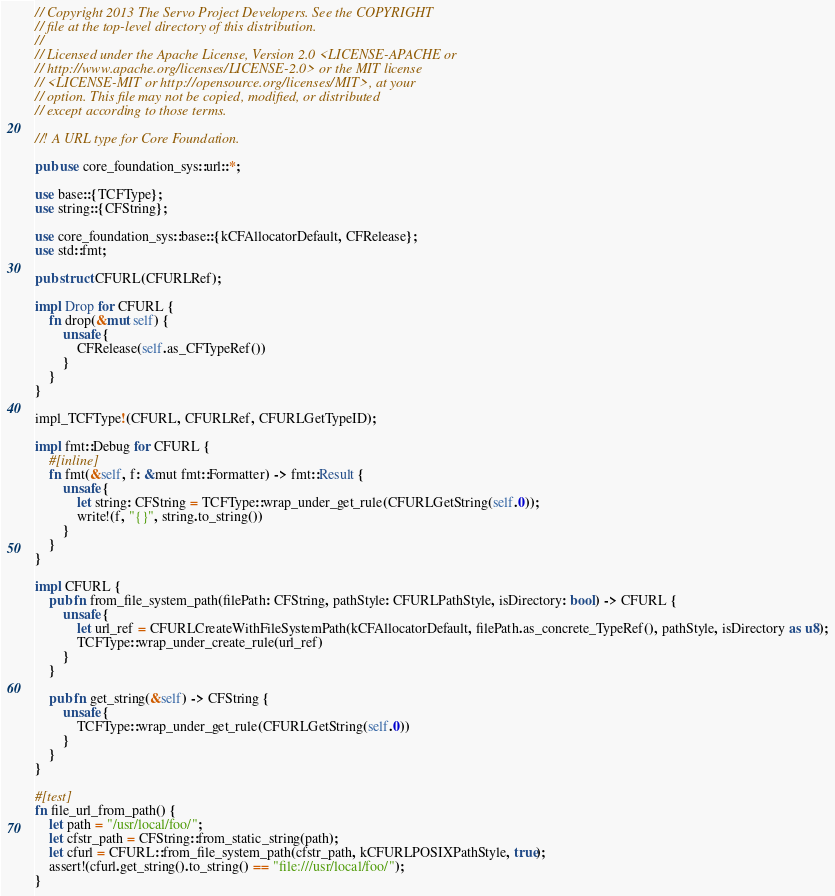<code> <loc_0><loc_0><loc_500><loc_500><_Rust_>// Copyright 2013 The Servo Project Developers. See the COPYRIGHT
// file at the top-level directory of this distribution.
//
// Licensed under the Apache License, Version 2.0 <LICENSE-APACHE or
// http://www.apache.org/licenses/LICENSE-2.0> or the MIT license
// <LICENSE-MIT or http://opensource.org/licenses/MIT>, at your
// option. This file may not be copied, modified, or distributed
// except according to those terms.

//! A URL type for Core Foundation.

pub use core_foundation_sys::url::*;

use base::{TCFType};
use string::{CFString};

use core_foundation_sys::base::{kCFAllocatorDefault, CFRelease};
use std::fmt;

pub struct CFURL(CFURLRef);

impl Drop for CFURL {
    fn drop(&mut self) {
        unsafe {
            CFRelease(self.as_CFTypeRef())
        }
    }
}

impl_TCFType!(CFURL, CFURLRef, CFURLGetTypeID);

impl fmt::Debug for CFURL {
    #[inline]
    fn fmt(&self, f: &mut fmt::Formatter) -> fmt::Result {
        unsafe {
            let string: CFString = TCFType::wrap_under_get_rule(CFURLGetString(self.0));
            write!(f, "{}", string.to_string())
        }
    }
}

impl CFURL {
    pub fn from_file_system_path(filePath: CFString, pathStyle: CFURLPathStyle, isDirectory: bool) -> CFURL {
        unsafe {
            let url_ref = CFURLCreateWithFileSystemPath(kCFAllocatorDefault, filePath.as_concrete_TypeRef(), pathStyle, isDirectory as u8);
            TCFType::wrap_under_create_rule(url_ref)
        }
    }

    pub fn get_string(&self) -> CFString {
        unsafe {
            TCFType::wrap_under_get_rule(CFURLGetString(self.0))
        }
    }
}

#[test]
fn file_url_from_path() {
    let path = "/usr/local/foo/";
    let cfstr_path = CFString::from_static_string(path);
    let cfurl = CFURL::from_file_system_path(cfstr_path, kCFURLPOSIXPathStyle, true);
    assert!(cfurl.get_string().to_string() == "file:///usr/local/foo/");
}
</code> 